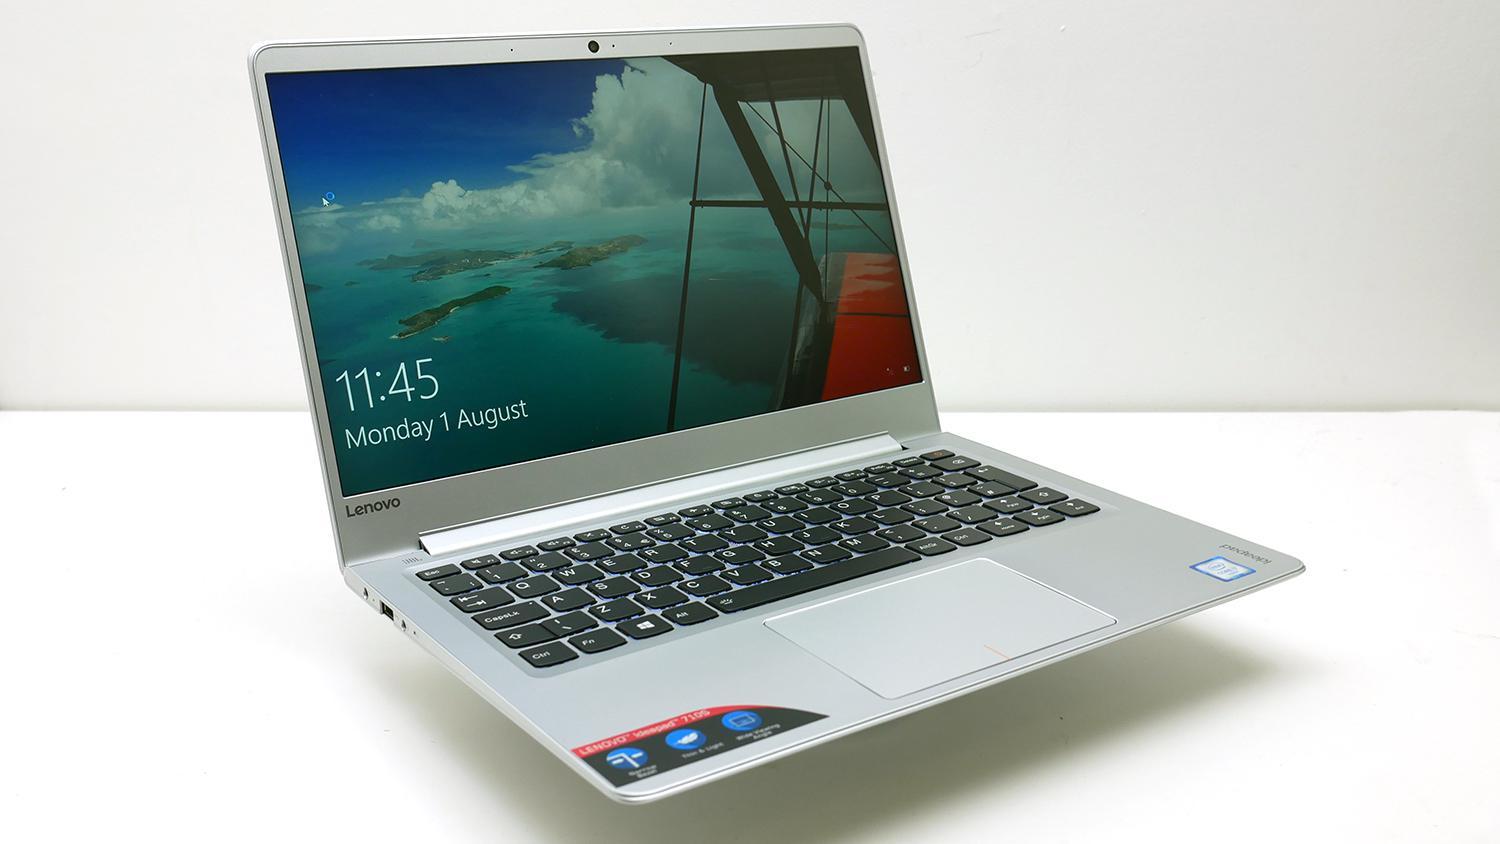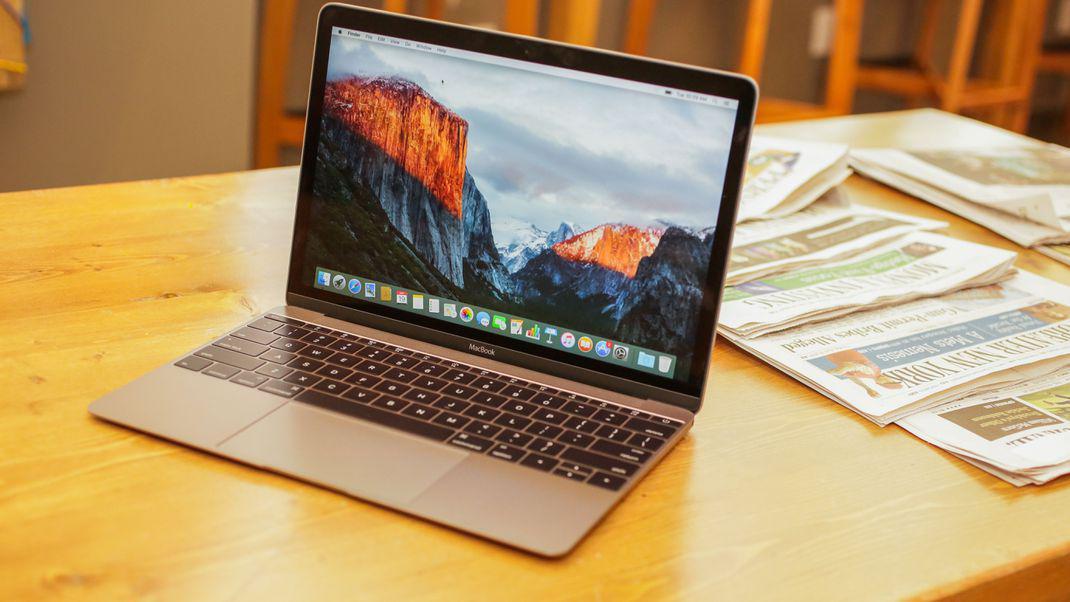The first image is the image on the left, the second image is the image on the right. For the images shown, is this caption "Both computers are facing the left." true? Answer yes or no. No. The first image is the image on the left, the second image is the image on the right. Evaluate the accuracy of this statement regarding the images: "Both images show an open laptop tilted so the screen aims leftward.". Is it true? Answer yes or no. No. 